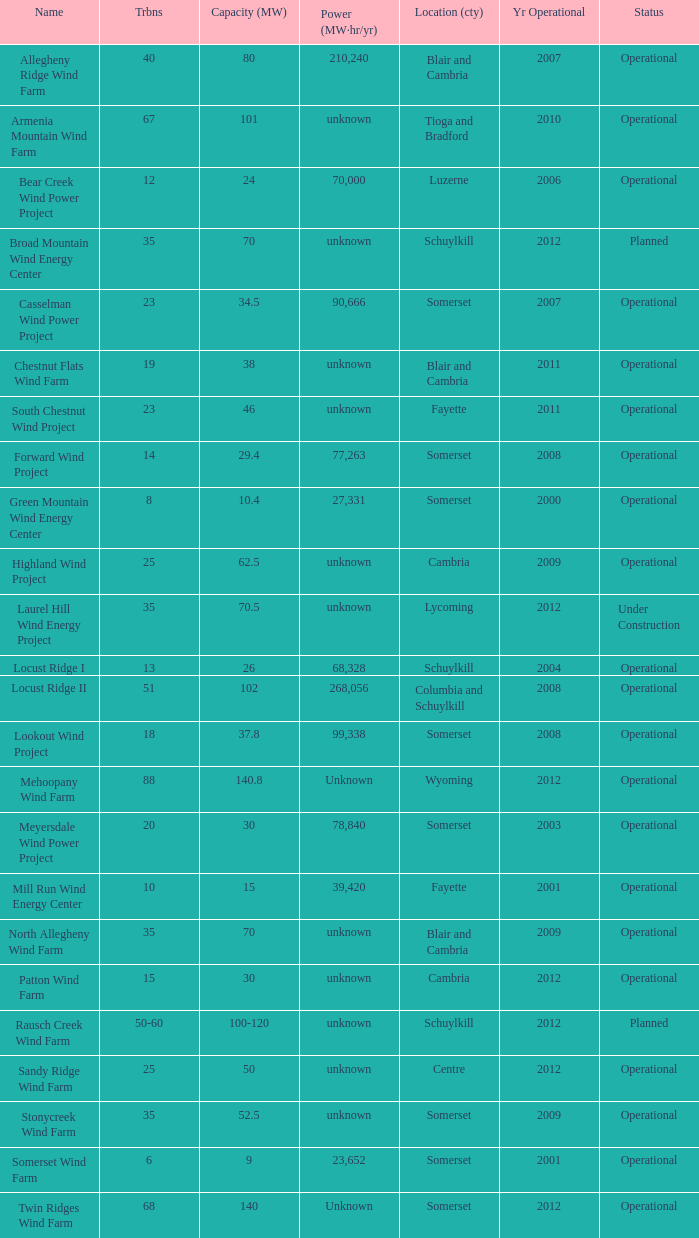What farm has a capacity of 70 and is operational? North Allegheny Wind Farm. 